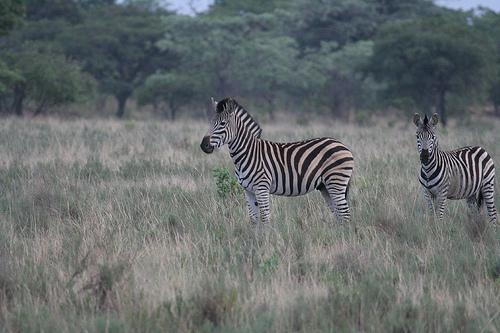Question: what is in the field?
Choices:
A. Giraffes.
B. Lions.
C. Zebras.
D. Gazelles.
Answer with the letter. Answer: C Question: where are the zebras?
Choices:
A. In the desert.
B. In Africa.
C. In the savannah.
D. In the grassland.
Answer with the letter. Answer: B Question: what is in the background?
Choices:
A. Ocean.
B. Bushes.
C. Lake.
D. Trees.
Answer with the letter. Answer: D Question: what are the zebras standing in?
Choices:
A. Reeds.
B. Tall grass.
C. Tall weeds.
D. Shrubs.
Answer with the letter. Answer: B Question: what pattern are the zebras' coats?
Choices:
A. Lined.
B. Columns.
C. Striped.
D. Spaces.
Answer with the letter. Answer: C Question: when was this picture taken?
Choices:
A. Night time.
B. During the daytime.
C. Early morning.
D. Dusk.
Answer with the letter. Answer: B 